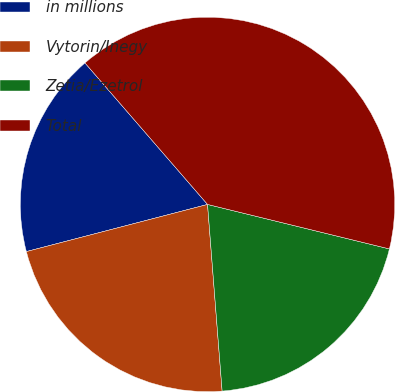<chart> <loc_0><loc_0><loc_500><loc_500><pie_chart><fcel>in millions<fcel>Vytorin/Inegy<fcel>Zetia/Ezetrol<fcel>Total<nl><fcel>17.69%<fcel>22.19%<fcel>19.94%<fcel>40.18%<nl></chart> 